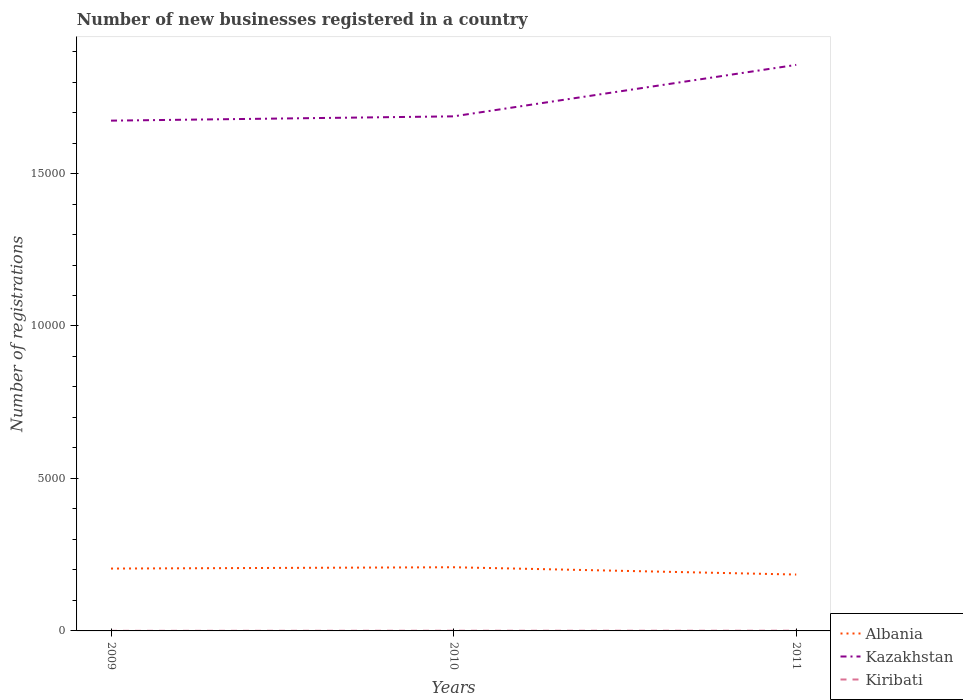How many different coloured lines are there?
Give a very brief answer. 3. In which year was the number of new businesses registered in Kazakhstan maximum?
Provide a short and direct response. 2009. What is the total number of new businesses registered in Kiribati in the graph?
Give a very brief answer. -4. What is the difference between the highest and the second highest number of new businesses registered in Kiribati?
Keep it short and to the point. 4. How many years are there in the graph?
Keep it short and to the point. 3. What is the difference between two consecutive major ticks on the Y-axis?
Provide a succinct answer. 5000. Are the values on the major ticks of Y-axis written in scientific E-notation?
Provide a short and direct response. No. Does the graph contain any zero values?
Your answer should be compact. No. Does the graph contain grids?
Make the answer very short. No. How many legend labels are there?
Keep it short and to the point. 3. How are the legend labels stacked?
Your answer should be very brief. Vertical. What is the title of the graph?
Offer a terse response. Number of new businesses registered in a country. Does "Benin" appear as one of the legend labels in the graph?
Offer a very short reply. No. What is the label or title of the Y-axis?
Offer a very short reply. Number of registrations. What is the Number of registrations in Albania in 2009?
Keep it short and to the point. 2045. What is the Number of registrations of Kazakhstan in 2009?
Offer a terse response. 1.67e+04. What is the Number of registrations of Albania in 2010?
Make the answer very short. 2088. What is the Number of registrations of Kazakhstan in 2010?
Your response must be concise. 1.69e+04. What is the Number of registrations of Kiribati in 2010?
Offer a very short reply. 6. What is the Number of registrations in Albania in 2011?
Offer a terse response. 1849. What is the Number of registrations in Kazakhstan in 2011?
Your answer should be compact. 1.86e+04. Across all years, what is the maximum Number of registrations of Albania?
Keep it short and to the point. 2088. Across all years, what is the maximum Number of registrations of Kazakhstan?
Keep it short and to the point. 1.86e+04. Across all years, what is the maximum Number of registrations in Kiribati?
Provide a succinct answer. 7. Across all years, what is the minimum Number of registrations in Albania?
Make the answer very short. 1849. Across all years, what is the minimum Number of registrations in Kazakhstan?
Provide a succinct answer. 1.67e+04. What is the total Number of registrations of Albania in the graph?
Your answer should be compact. 5982. What is the total Number of registrations of Kazakhstan in the graph?
Your response must be concise. 5.22e+04. What is the total Number of registrations in Kiribati in the graph?
Your answer should be compact. 16. What is the difference between the Number of registrations in Albania in 2009 and that in 2010?
Your answer should be compact. -43. What is the difference between the Number of registrations in Kazakhstan in 2009 and that in 2010?
Your answer should be compact. -141. What is the difference between the Number of registrations of Kiribati in 2009 and that in 2010?
Your answer should be compact. -3. What is the difference between the Number of registrations of Albania in 2009 and that in 2011?
Offer a terse response. 196. What is the difference between the Number of registrations of Kazakhstan in 2009 and that in 2011?
Your response must be concise. -1829. What is the difference between the Number of registrations in Kiribati in 2009 and that in 2011?
Ensure brevity in your answer.  -4. What is the difference between the Number of registrations in Albania in 2010 and that in 2011?
Offer a very short reply. 239. What is the difference between the Number of registrations of Kazakhstan in 2010 and that in 2011?
Your response must be concise. -1688. What is the difference between the Number of registrations in Kiribati in 2010 and that in 2011?
Keep it short and to the point. -1. What is the difference between the Number of registrations of Albania in 2009 and the Number of registrations of Kazakhstan in 2010?
Offer a very short reply. -1.48e+04. What is the difference between the Number of registrations of Albania in 2009 and the Number of registrations of Kiribati in 2010?
Keep it short and to the point. 2039. What is the difference between the Number of registrations in Kazakhstan in 2009 and the Number of registrations in Kiribati in 2010?
Provide a short and direct response. 1.67e+04. What is the difference between the Number of registrations in Albania in 2009 and the Number of registrations in Kazakhstan in 2011?
Your answer should be very brief. -1.65e+04. What is the difference between the Number of registrations in Albania in 2009 and the Number of registrations in Kiribati in 2011?
Give a very brief answer. 2038. What is the difference between the Number of registrations of Kazakhstan in 2009 and the Number of registrations of Kiribati in 2011?
Your answer should be compact. 1.67e+04. What is the difference between the Number of registrations in Albania in 2010 and the Number of registrations in Kazakhstan in 2011?
Provide a succinct answer. -1.65e+04. What is the difference between the Number of registrations of Albania in 2010 and the Number of registrations of Kiribati in 2011?
Your answer should be compact. 2081. What is the difference between the Number of registrations in Kazakhstan in 2010 and the Number of registrations in Kiribati in 2011?
Give a very brief answer. 1.69e+04. What is the average Number of registrations in Albania per year?
Give a very brief answer. 1994. What is the average Number of registrations in Kazakhstan per year?
Make the answer very short. 1.74e+04. What is the average Number of registrations in Kiribati per year?
Make the answer very short. 5.33. In the year 2009, what is the difference between the Number of registrations of Albania and Number of registrations of Kazakhstan?
Your answer should be compact. -1.47e+04. In the year 2009, what is the difference between the Number of registrations of Albania and Number of registrations of Kiribati?
Keep it short and to the point. 2042. In the year 2009, what is the difference between the Number of registrations in Kazakhstan and Number of registrations in Kiribati?
Your answer should be very brief. 1.67e+04. In the year 2010, what is the difference between the Number of registrations of Albania and Number of registrations of Kazakhstan?
Offer a terse response. -1.48e+04. In the year 2010, what is the difference between the Number of registrations in Albania and Number of registrations in Kiribati?
Keep it short and to the point. 2082. In the year 2010, what is the difference between the Number of registrations of Kazakhstan and Number of registrations of Kiribati?
Your answer should be compact. 1.69e+04. In the year 2011, what is the difference between the Number of registrations of Albania and Number of registrations of Kazakhstan?
Provide a short and direct response. -1.67e+04. In the year 2011, what is the difference between the Number of registrations of Albania and Number of registrations of Kiribati?
Provide a short and direct response. 1842. In the year 2011, what is the difference between the Number of registrations in Kazakhstan and Number of registrations in Kiribati?
Ensure brevity in your answer.  1.86e+04. What is the ratio of the Number of registrations in Albania in 2009 to that in 2010?
Offer a terse response. 0.98. What is the ratio of the Number of registrations in Kazakhstan in 2009 to that in 2010?
Make the answer very short. 0.99. What is the ratio of the Number of registrations in Kiribati in 2009 to that in 2010?
Your answer should be compact. 0.5. What is the ratio of the Number of registrations of Albania in 2009 to that in 2011?
Ensure brevity in your answer.  1.11. What is the ratio of the Number of registrations in Kazakhstan in 2009 to that in 2011?
Keep it short and to the point. 0.9. What is the ratio of the Number of registrations in Kiribati in 2009 to that in 2011?
Ensure brevity in your answer.  0.43. What is the ratio of the Number of registrations in Albania in 2010 to that in 2011?
Your answer should be very brief. 1.13. What is the ratio of the Number of registrations in Kazakhstan in 2010 to that in 2011?
Offer a terse response. 0.91. What is the difference between the highest and the second highest Number of registrations in Kazakhstan?
Provide a short and direct response. 1688. What is the difference between the highest and the second highest Number of registrations of Kiribati?
Make the answer very short. 1. What is the difference between the highest and the lowest Number of registrations of Albania?
Your answer should be compact. 239. What is the difference between the highest and the lowest Number of registrations in Kazakhstan?
Your answer should be compact. 1829. 